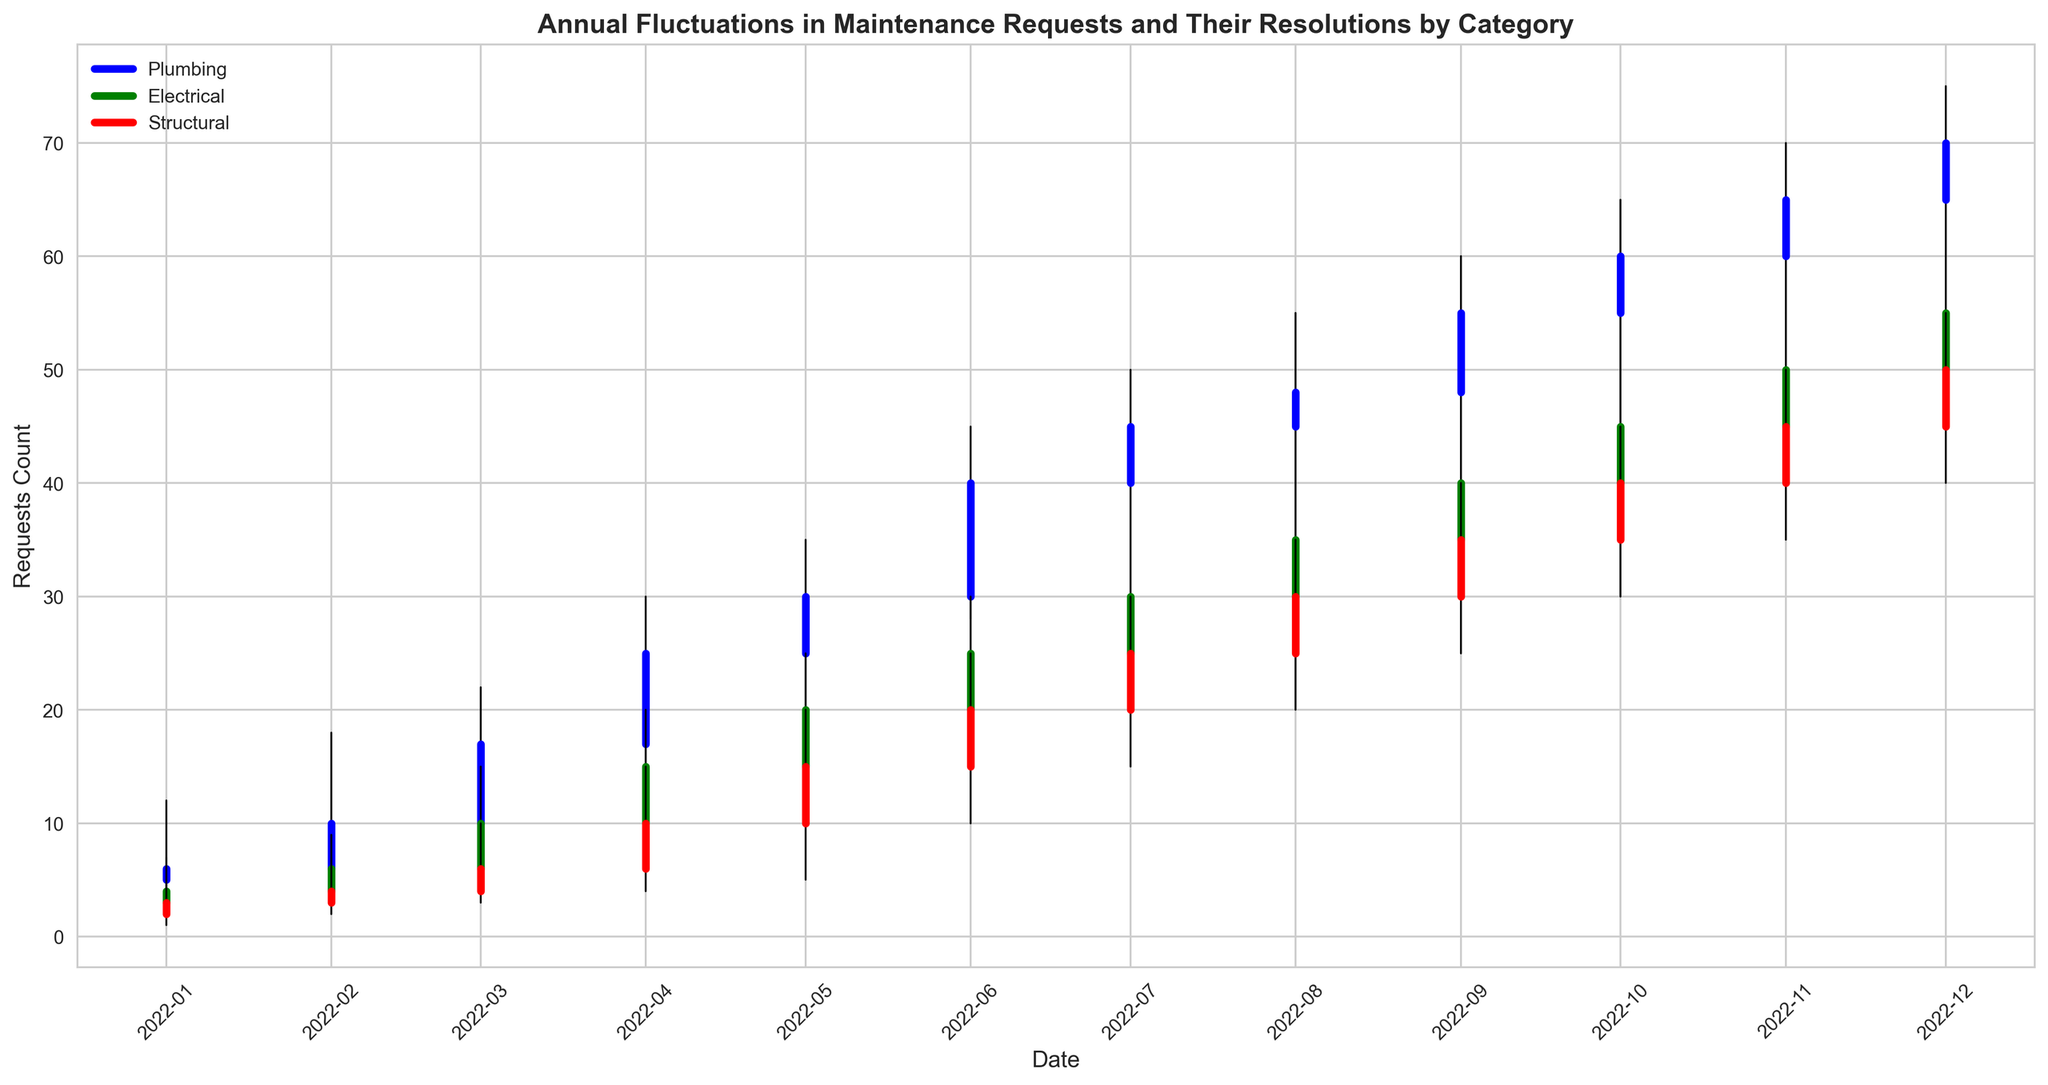What is the highest number of plumbing maintenance requests in a month? Identify the highest point in the plot for the plumbing requests, which is marked in blue.
Answer: 75 In which month did electrical requests see the biggest increase from the previous month? Compare the opening and closing values month-over-month, specifically looking for the largest positive difference for electrical requests, marked in green. March shows the largest increase (6 to 10).
Answer: March What is the lowest number of structural requests in any month? Identify the lowest point in the plot for the structural requests, which is marked in red.
Answer: 1 In October, which category had the lowest number of closed requests? Compare the closed requests for Plumbing, Electrical, and Structural categories in October.
Answer: Electrical Which category showed a consistent month-to-month increase throughout the year? Examine the plot lines for each category. The plumbing category shows a consistent increase each month.
Answer: Plumbing What’s the average high request count for the electrical category across the year? Sum the high request counts for electrical (7, 9, 15, 20, 25, 30, 35, 38, 45, 50, 55, 60) and divide by 12. (7+9+15+20+25+30+35+38+45+50+55+60) / 12 = 439 / 12 ≈ 36.58
Answer: 36.58 Which month shows the highest number of unresolved plumbing requests? Identify the month with the largest difference between open and close values for plumbing. June shows the highest open (30) and close (40).
Answer: June During which month do all three categories show a closing value of 50 or above? Examine the closing values across categories for each month. In December, all categories (Plumbing, Electrical, Structural) close at or above 50.
Answer: December What is the combined closing value for all categories in May? Sum the closing values for Plumbing (30), Electrical (20), and Structural (15) in May. 30 + 20 + 15 = 65
Answer: 65 Comparing the high request counts in July, which category had the second-highest peak? Examine the high request counts in July for all categories. Electrical had the second-highest with a peak of 35.
Answer: Electrical 